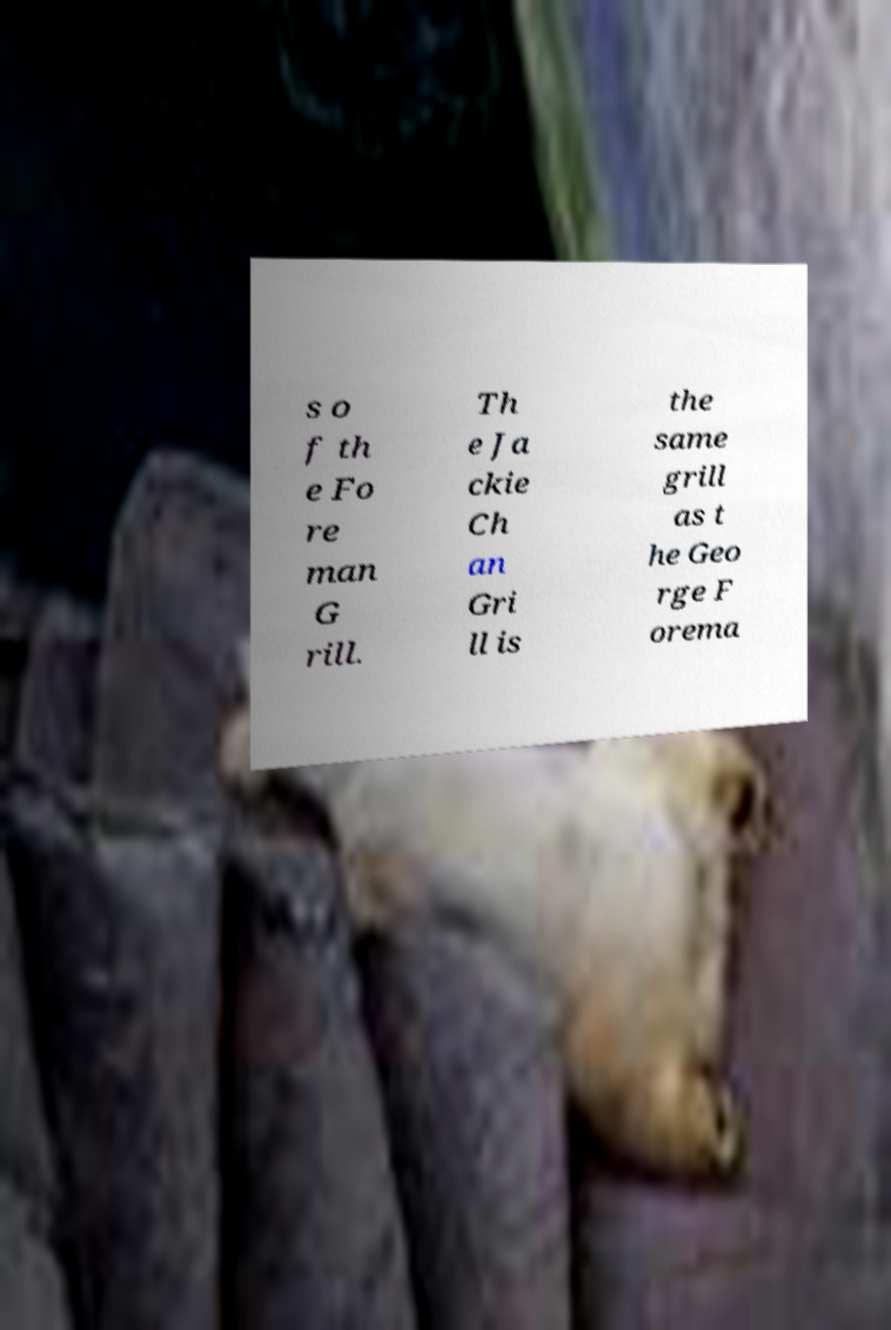For documentation purposes, I need the text within this image transcribed. Could you provide that? s o f th e Fo re man G rill. Th e Ja ckie Ch an Gri ll is the same grill as t he Geo rge F orema 